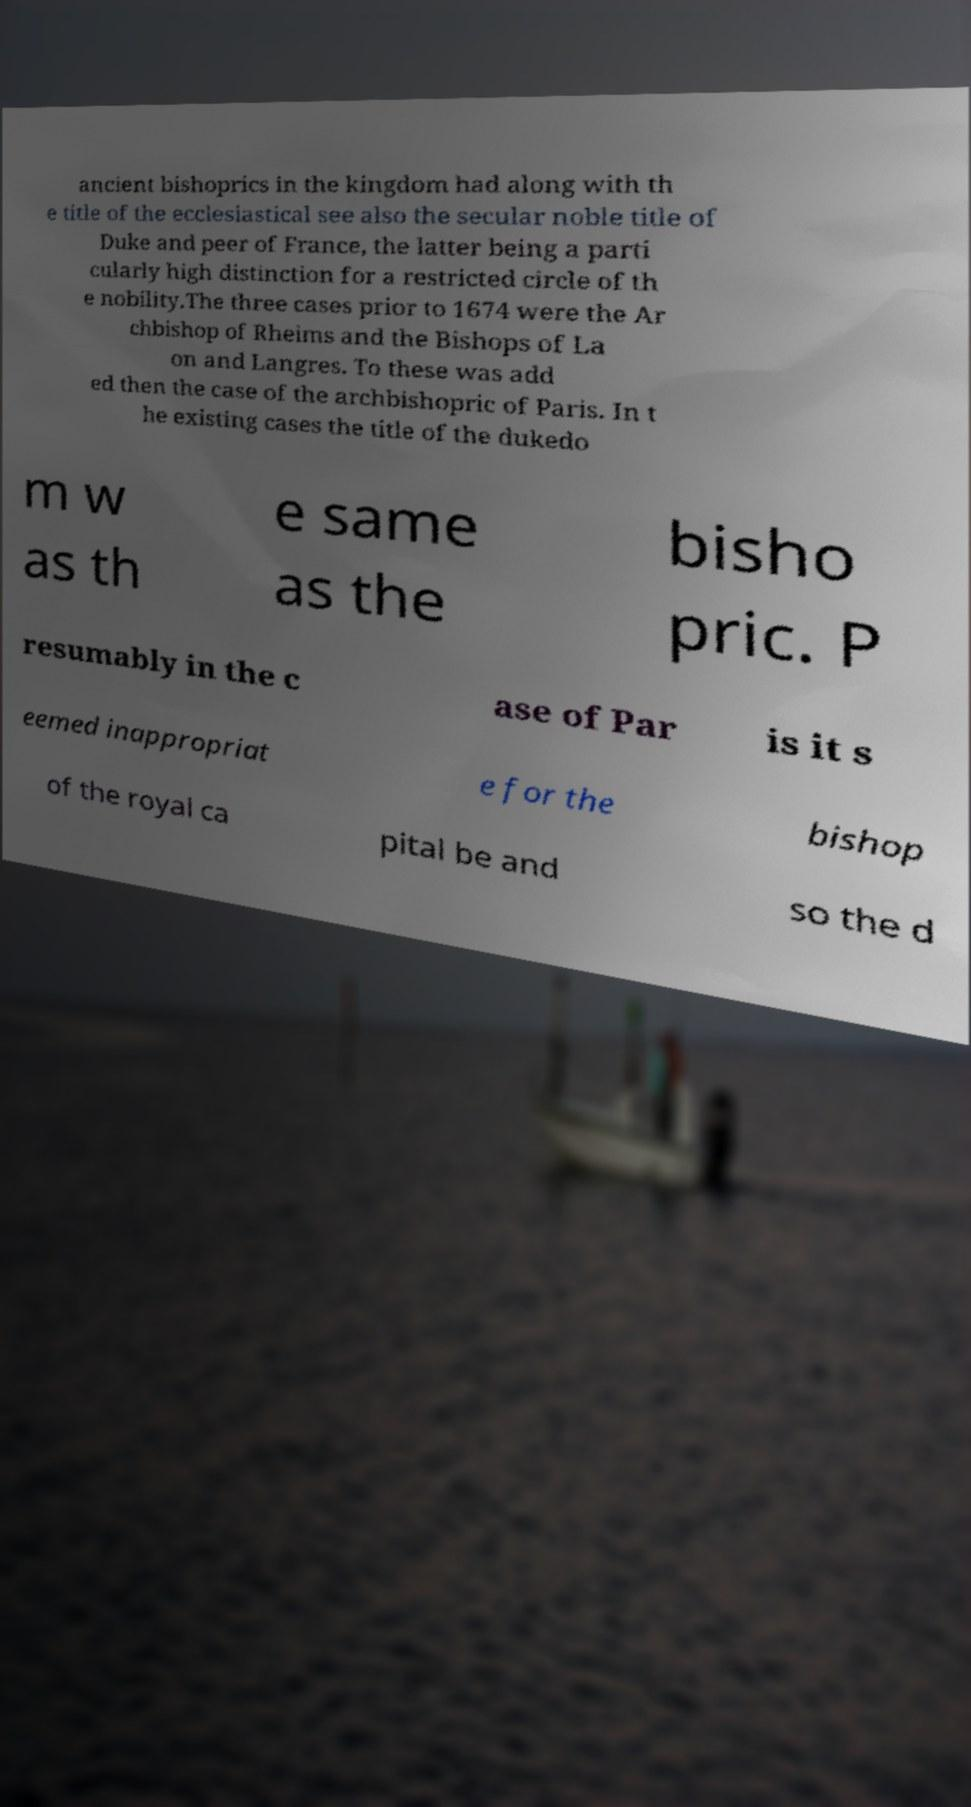I need the written content from this picture converted into text. Can you do that? ancient bishoprics in the kingdom had along with th e title of the ecclesiastical see also the secular noble title of Duke and peer of France, the latter being a parti cularly high distinction for a restricted circle of th e nobility.The three cases prior to 1674 were the Ar chbishop of Rheims and the Bishops of La on and Langres. To these was add ed then the case of the archbishopric of Paris. In t he existing cases the title of the dukedo m w as th e same as the bisho pric. P resumably in the c ase of Par is it s eemed inappropriat e for the bishop of the royal ca pital be and so the d 